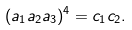<formula> <loc_0><loc_0><loc_500><loc_500>( a _ { 1 } a _ { 2 } a _ { 3 } ) ^ { 4 } = c _ { 1 } c _ { 2 } .</formula> 